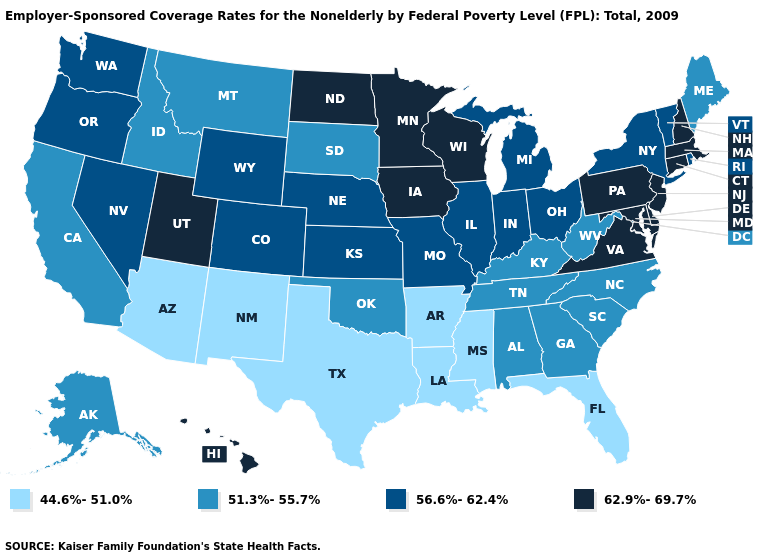Which states hav the highest value in the MidWest?
Write a very short answer. Iowa, Minnesota, North Dakota, Wisconsin. Name the states that have a value in the range 44.6%-51.0%?
Concise answer only. Arizona, Arkansas, Florida, Louisiana, Mississippi, New Mexico, Texas. What is the highest value in states that border New Mexico?
Quick response, please. 62.9%-69.7%. How many symbols are there in the legend?
Concise answer only. 4. Which states have the highest value in the USA?
Quick response, please. Connecticut, Delaware, Hawaii, Iowa, Maryland, Massachusetts, Minnesota, New Hampshire, New Jersey, North Dakota, Pennsylvania, Utah, Virginia, Wisconsin. What is the value of Georgia?
Give a very brief answer. 51.3%-55.7%. What is the value of Nebraska?
Short answer required. 56.6%-62.4%. What is the lowest value in states that border Connecticut?
Concise answer only. 56.6%-62.4%. Name the states that have a value in the range 51.3%-55.7%?
Write a very short answer. Alabama, Alaska, California, Georgia, Idaho, Kentucky, Maine, Montana, North Carolina, Oklahoma, South Carolina, South Dakota, Tennessee, West Virginia. What is the highest value in the USA?
Concise answer only. 62.9%-69.7%. What is the value of California?
Quick response, please. 51.3%-55.7%. Name the states that have a value in the range 51.3%-55.7%?
Be succinct. Alabama, Alaska, California, Georgia, Idaho, Kentucky, Maine, Montana, North Carolina, Oklahoma, South Carolina, South Dakota, Tennessee, West Virginia. Is the legend a continuous bar?
Write a very short answer. No. Name the states that have a value in the range 62.9%-69.7%?
Keep it brief. Connecticut, Delaware, Hawaii, Iowa, Maryland, Massachusetts, Minnesota, New Hampshire, New Jersey, North Dakota, Pennsylvania, Utah, Virginia, Wisconsin. What is the lowest value in the USA?
Keep it brief. 44.6%-51.0%. 